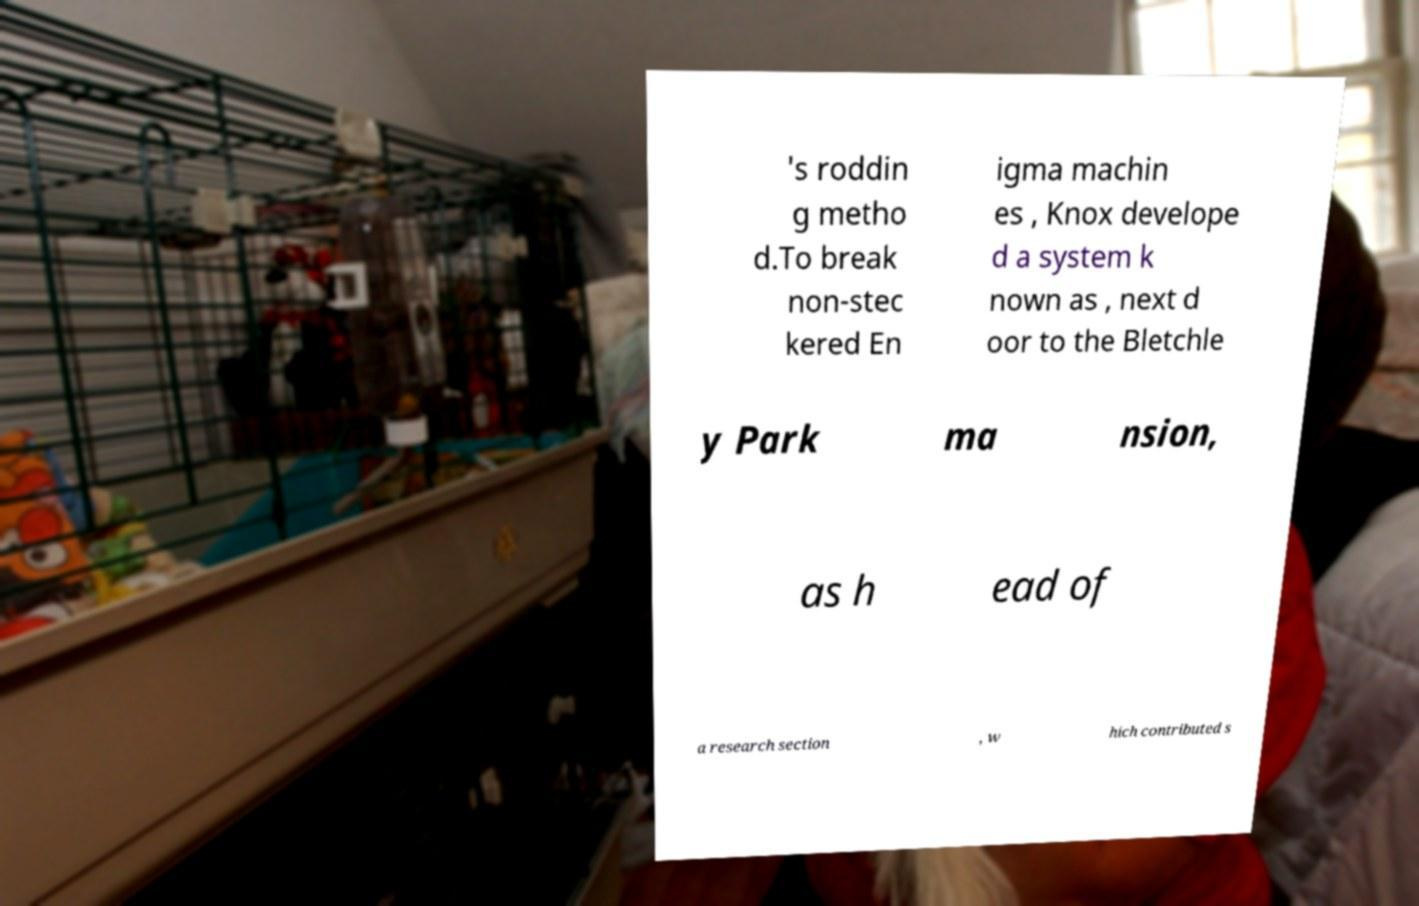Can you read and provide the text displayed in the image?This photo seems to have some interesting text. Can you extract and type it out for me? 's roddin g metho d.To break non-stec kered En igma machin es , Knox develope d a system k nown as , next d oor to the Bletchle y Park ma nsion, as h ead of a research section , w hich contributed s 